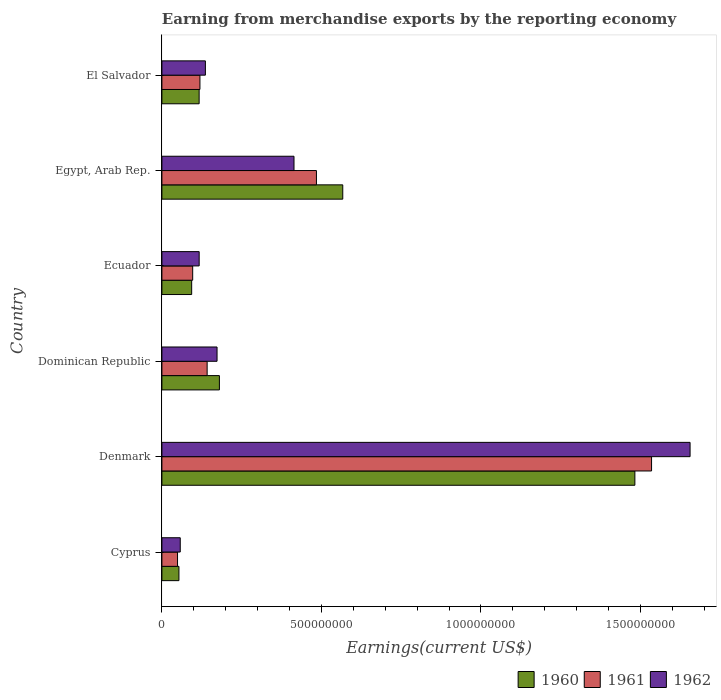Are the number of bars per tick equal to the number of legend labels?
Make the answer very short. Yes. How many bars are there on the 3rd tick from the top?
Ensure brevity in your answer.  3. What is the label of the 3rd group of bars from the top?
Provide a short and direct response. Ecuador. In how many cases, is the number of bars for a given country not equal to the number of legend labels?
Provide a succinct answer. 0. What is the amount earned from merchandise exports in 1961 in Dominican Republic?
Make the answer very short. 1.42e+08. Across all countries, what is the maximum amount earned from merchandise exports in 1961?
Make the answer very short. 1.53e+09. Across all countries, what is the minimum amount earned from merchandise exports in 1961?
Make the answer very short. 4.90e+07. In which country was the amount earned from merchandise exports in 1961 minimum?
Keep it short and to the point. Cyprus. What is the total amount earned from merchandise exports in 1960 in the graph?
Keep it short and to the point. 2.49e+09. What is the difference between the amount earned from merchandise exports in 1962 in Cyprus and that in Ecuador?
Your answer should be compact. -5.93e+07. What is the difference between the amount earned from merchandise exports in 1961 in El Salvador and the amount earned from merchandise exports in 1962 in Dominican Republic?
Provide a short and direct response. -5.36e+07. What is the average amount earned from merchandise exports in 1962 per country?
Offer a very short reply. 4.25e+08. What is the difference between the amount earned from merchandise exports in 1961 and amount earned from merchandise exports in 1960 in Egypt, Arab Rep.?
Your answer should be compact. -8.25e+07. In how many countries, is the amount earned from merchandise exports in 1962 greater than 1500000000 US$?
Your answer should be very brief. 1. What is the ratio of the amount earned from merchandise exports in 1960 in Denmark to that in Dominican Republic?
Ensure brevity in your answer.  8.23. What is the difference between the highest and the second highest amount earned from merchandise exports in 1960?
Your response must be concise. 9.16e+08. What is the difference between the highest and the lowest amount earned from merchandise exports in 1961?
Keep it short and to the point. 1.49e+09. Is the sum of the amount earned from merchandise exports in 1961 in Cyprus and Egypt, Arab Rep. greater than the maximum amount earned from merchandise exports in 1960 across all countries?
Your answer should be compact. No. What does the 3rd bar from the top in Denmark represents?
Your answer should be very brief. 1960. Is it the case that in every country, the sum of the amount earned from merchandise exports in 1962 and amount earned from merchandise exports in 1960 is greater than the amount earned from merchandise exports in 1961?
Provide a succinct answer. Yes. How many bars are there?
Ensure brevity in your answer.  18. How many countries are there in the graph?
Provide a short and direct response. 6. What is the difference between two consecutive major ticks on the X-axis?
Your answer should be very brief. 5.00e+08. Are the values on the major ticks of X-axis written in scientific E-notation?
Provide a short and direct response. No. Does the graph contain any zero values?
Offer a terse response. No. What is the title of the graph?
Offer a very short reply. Earning from merchandise exports by the reporting economy. Does "2002" appear as one of the legend labels in the graph?
Give a very brief answer. No. What is the label or title of the X-axis?
Ensure brevity in your answer.  Earnings(current US$). What is the Earnings(current US$) of 1960 in Cyprus?
Give a very brief answer. 5.34e+07. What is the Earnings(current US$) of 1961 in Cyprus?
Provide a succinct answer. 4.90e+07. What is the Earnings(current US$) in 1962 in Cyprus?
Your answer should be compact. 5.75e+07. What is the Earnings(current US$) in 1960 in Denmark?
Your response must be concise. 1.48e+09. What is the Earnings(current US$) in 1961 in Denmark?
Provide a succinct answer. 1.53e+09. What is the Earnings(current US$) in 1962 in Denmark?
Make the answer very short. 1.66e+09. What is the Earnings(current US$) of 1960 in Dominican Republic?
Keep it short and to the point. 1.80e+08. What is the Earnings(current US$) of 1961 in Dominican Republic?
Give a very brief answer. 1.42e+08. What is the Earnings(current US$) of 1962 in Dominican Republic?
Offer a terse response. 1.73e+08. What is the Earnings(current US$) in 1960 in Ecuador?
Make the answer very short. 9.33e+07. What is the Earnings(current US$) in 1961 in Ecuador?
Your response must be concise. 9.65e+07. What is the Earnings(current US$) in 1962 in Ecuador?
Make the answer very short. 1.17e+08. What is the Earnings(current US$) in 1960 in Egypt, Arab Rep.?
Give a very brief answer. 5.67e+08. What is the Earnings(current US$) in 1961 in Egypt, Arab Rep.?
Provide a short and direct response. 4.84e+08. What is the Earnings(current US$) of 1962 in Egypt, Arab Rep.?
Keep it short and to the point. 4.14e+08. What is the Earnings(current US$) in 1960 in El Salvador?
Offer a very short reply. 1.17e+08. What is the Earnings(current US$) of 1961 in El Salvador?
Your answer should be compact. 1.19e+08. What is the Earnings(current US$) in 1962 in El Salvador?
Your response must be concise. 1.36e+08. Across all countries, what is the maximum Earnings(current US$) in 1960?
Your answer should be very brief. 1.48e+09. Across all countries, what is the maximum Earnings(current US$) of 1961?
Offer a very short reply. 1.53e+09. Across all countries, what is the maximum Earnings(current US$) of 1962?
Keep it short and to the point. 1.66e+09. Across all countries, what is the minimum Earnings(current US$) in 1960?
Ensure brevity in your answer.  5.34e+07. Across all countries, what is the minimum Earnings(current US$) in 1961?
Ensure brevity in your answer.  4.90e+07. Across all countries, what is the minimum Earnings(current US$) in 1962?
Keep it short and to the point. 5.75e+07. What is the total Earnings(current US$) of 1960 in the graph?
Your response must be concise. 2.49e+09. What is the total Earnings(current US$) in 1961 in the graph?
Your response must be concise. 2.43e+09. What is the total Earnings(current US$) of 1962 in the graph?
Your response must be concise. 2.55e+09. What is the difference between the Earnings(current US$) of 1960 in Cyprus and that in Denmark?
Ensure brevity in your answer.  -1.43e+09. What is the difference between the Earnings(current US$) of 1961 in Cyprus and that in Denmark?
Give a very brief answer. -1.49e+09. What is the difference between the Earnings(current US$) of 1962 in Cyprus and that in Denmark?
Keep it short and to the point. -1.60e+09. What is the difference between the Earnings(current US$) in 1960 in Cyprus and that in Dominican Republic?
Make the answer very short. -1.27e+08. What is the difference between the Earnings(current US$) in 1961 in Cyprus and that in Dominican Republic?
Ensure brevity in your answer.  -9.28e+07. What is the difference between the Earnings(current US$) in 1962 in Cyprus and that in Dominican Republic?
Your answer should be very brief. -1.15e+08. What is the difference between the Earnings(current US$) of 1960 in Cyprus and that in Ecuador?
Provide a succinct answer. -3.99e+07. What is the difference between the Earnings(current US$) in 1961 in Cyprus and that in Ecuador?
Offer a very short reply. -4.75e+07. What is the difference between the Earnings(current US$) in 1962 in Cyprus and that in Ecuador?
Your answer should be compact. -5.93e+07. What is the difference between the Earnings(current US$) of 1960 in Cyprus and that in Egypt, Arab Rep.?
Make the answer very short. -5.13e+08. What is the difference between the Earnings(current US$) of 1961 in Cyprus and that in Egypt, Arab Rep.?
Provide a short and direct response. -4.35e+08. What is the difference between the Earnings(current US$) of 1962 in Cyprus and that in Egypt, Arab Rep.?
Keep it short and to the point. -3.56e+08. What is the difference between the Earnings(current US$) in 1960 in Cyprus and that in El Salvador?
Your answer should be compact. -6.33e+07. What is the difference between the Earnings(current US$) in 1961 in Cyprus and that in El Salvador?
Keep it short and to the point. -7.02e+07. What is the difference between the Earnings(current US$) of 1962 in Cyprus and that in El Salvador?
Ensure brevity in your answer.  -7.88e+07. What is the difference between the Earnings(current US$) of 1960 in Denmark and that in Dominican Republic?
Make the answer very short. 1.30e+09. What is the difference between the Earnings(current US$) in 1961 in Denmark and that in Dominican Republic?
Give a very brief answer. 1.39e+09. What is the difference between the Earnings(current US$) in 1962 in Denmark and that in Dominican Republic?
Your answer should be very brief. 1.48e+09. What is the difference between the Earnings(current US$) of 1960 in Denmark and that in Ecuador?
Your answer should be very brief. 1.39e+09. What is the difference between the Earnings(current US$) of 1961 in Denmark and that in Ecuador?
Offer a terse response. 1.44e+09. What is the difference between the Earnings(current US$) in 1962 in Denmark and that in Ecuador?
Provide a short and direct response. 1.54e+09. What is the difference between the Earnings(current US$) in 1960 in Denmark and that in Egypt, Arab Rep.?
Offer a very short reply. 9.16e+08. What is the difference between the Earnings(current US$) of 1961 in Denmark and that in Egypt, Arab Rep.?
Provide a succinct answer. 1.05e+09. What is the difference between the Earnings(current US$) in 1962 in Denmark and that in Egypt, Arab Rep.?
Provide a short and direct response. 1.24e+09. What is the difference between the Earnings(current US$) in 1960 in Denmark and that in El Salvador?
Offer a very short reply. 1.37e+09. What is the difference between the Earnings(current US$) of 1961 in Denmark and that in El Salvador?
Provide a short and direct response. 1.42e+09. What is the difference between the Earnings(current US$) of 1962 in Denmark and that in El Salvador?
Make the answer very short. 1.52e+09. What is the difference between the Earnings(current US$) in 1960 in Dominican Republic and that in Ecuador?
Make the answer very short. 8.69e+07. What is the difference between the Earnings(current US$) in 1961 in Dominican Republic and that in Ecuador?
Your response must be concise. 4.53e+07. What is the difference between the Earnings(current US$) in 1962 in Dominican Republic and that in Ecuador?
Your answer should be very brief. 5.60e+07. What is the difference between the Earnings(current US$) in 1960 in Dominican Republic and that in Egypt, Arab Rep.?
Make the answer very short. -3.87e+08. What is the difference between the Earnings(current US$) in 1961 in Dominican Republic and that in Egypt, Arab Rep.?
Offer a terse response. -3.42e+08. What is the difference between the Earnings(current US$) in 1962 in Dominican Republic and that in Egypt, Arab Rep.?
Offer a terse response. -2.41e+08. What is the difference between the Earnings(current US$) of 1960 in Dominican Republic and that in El Salvador?
Provide a short and direct response. 6.35e+07. What is the difference between the Earnings(current US$) in 1961 in Dominican Republic and that in El Salvador?
Your answer should be compact. 2.26e+07. What is the difference between the Earnings(current US$) of 1962 in Dominican Republic and that in El Salvador?
Offer a very short reply. 3.65e+07. What is the difference between the Earnings(current US$) in 1960 in Ecuador and that in Egypt, Arab Rep.?
Offer a terse response. -4.74e+08. What is the difference between the Earnings(current US$) of 1961 in Ecuador and that in Egypt, Arab Rep.?
Your answer should be very brief. -3.88e+08. What is the difference between the Earnings(current US$) in 1962 in Ecuador and that in Egypt, Arab Rep.?
Provide a succinct answer. -2.97e+08. What is the difference between the Earnings(current US$) in 1960 in Ecuador and that in El Salvador?
Keep it short and to the point. -2.34e+07. What is the difference between the Earnings(current US$) of 1961 in Ecuador and that in El Salvador?
Your response must be concise. -2.27e+07. What is the difference between the Earnings(current US$) in 1962 in Ecuador and that in El Salvador?
Offer a very short reply. -1.95e+07. What is the difference between the Earnings(current US$) of 1960 in Egypt, Arab Rep. and that in El Salvador?
Your response must be concise. 4.50e+08. What is the difference between the Earnings(current US$) in 1961 in Egypt, Arab Rep. and that in El Salvador?
Give a very brief answer. 3.65e+08. What is the difference between the Earnings(current US$) in 1962 in Egypt, Arab Rep. and that in El Salvador?
Give a very brief answer. 2.78e+08. What is the difference between the Earnings(current US$) in 1960 in Cyprus and the Earnings(current US$) in 1961 in Denmark?
Ensure brevity in your answer.  -1.48e+09. What is the difference between the Earnings(current US$) of 1960 in Cyprus and the Earnings(current US$) of 1962 in Denmark?
Offer a terse response. -1.60e+09. What is the difference between the Earnings(current US$) in 1961 in Cyprus and the Earnings(current US$) in 1962 in Denmark?
Ensure brevity in your answer.  -1.61e+09. What is the difference between the Earnings(current US$) of 1960 in Cyprus and the Earnings(current US$) of 1961 in Dominican Republic?
Give a very brief answer. -8.84e+07. What is the difference between the Earnings(current US$) in 1960 in Cyprus and the Earnings(current US$) in 1962 in Dominican Republic?
Your response must be concise. -1.19e+08. What is the difference between the Earnings(current US$) in 1961 in Cyprus and the Earnings(current US$) in 1962 in Dominican Republic?
Provide a short and direct response. -1.24e+08. What is the difference between the Earnings(current US$) in 1960 in Cyprus and the Earnings(current US$) in 1961 in Ecuador?
Offer a very short reply. -4.31e+07. What is the difference between the Earnings(current US$) of 1960 in Cyprus and the Earnings(current US$) of 1962 in Ecuador?
Provide a succinct answer. -6.34e+07. What is the difference between the Earnings(current US$) in 1961 in Cyprus and the Earnings(current US$) in 1962 in Ecuador?
Give a very brief answer. -6.78e+07. What is the difference between the Earnings(current US$) of 1960 in Cyprus and the Earnings(current US$) of 1961 in Egypt, Arab Rep.?
Provide a short and direct response. -4.31e+08. What is the difference between the Earnings(current US$) of 1960 in Cyprus and the Earnings(current US$) of 1962 in Egypt, Arab Rep.?
Provide a succinct answer. -3.61e+08. What is the difference between the Earnings(current US$) of 1961 in Cyprus and the Earnings(current US$) of 1962 in Egypt, Arab Rep.?
Ensure brevity in your answer.  -3.65e+08. What is the difference between the Earnings(current US$) of 1960 in Cyprus and the Earnings(current US$) of 1961 in El Salvador?
Your answer should be compact. -6.58e+07. What is the difference between the Earnings(current US$) of 1960 in Cyprus and the Earnings(current US$) of 1962 in El Salvador?
Offer a very short reply. -8.29e+07. What is the difference between the Earnings(current US$) in 1961 in Cyprus and the Earnings(current US$) in 1962 in El Salvador?
Give a very brief answer. -8.73e+07. What is the difference between the Earnings(current US$) in 1960 in Denmark and the Earnings(current US$) in 1961 in Dominican Republic?
Make the answer very short. 1.34e+09. What is the difference between the Earnings(current US$) of 1960 in Denmark and the Earnings(current US$) of 1962 in Dominican Republic?
Your response must be concise. 1.31e+09. What is the difference between the Earnings(current US$) in 1961 in Denmark and the Earnings(current US$) in 1962 in Dominican Republic?
Ensure brevity in your answer.  1.36e+09. What is the difference between the Earnings(current US$) in 1960 in Denmark and the Earnings(current US$) in 1961 in Ecuador?
Your answer should be compact. 1.39e+09. What is the difference between the Earnings(current US$) in 1960 in Denmark and the Earnings(current US$) in 1962 in Ecuador?
Keep it short and to the point. 1.37e+09. What is the difference between the Earnings(current US$) of 1961 in Denmark and the Earnings(current US$) of 1962 in Ecuador?
Your answer should be compact. 1.42e+09. What is the difference between the Earnings(current US$) of 1960 in Denmark and the Earnings(current US$) of 1961 in Egypt, Arab Rep.?
Your answer should be very brief. 9.98e+08. What is the difference between the Earnings(current US$) of 1960 in Denmark and the Earnings(current US$) of 1962 in Egypt, Arab Rep.?
Your answer should be very brief. 1.07e+09. What is the difference between the Earnings(current US$) of 1961 in Denmark and the Earnings(current US$) of 1962 in Egypt, Arab Rep.?
Offer a very short reply. 1.12e+09. What is the difference between the Earnings(current US$) of 1960 in Denmark and the Earnings(current US$) of 1961 in El Salvador?
Your answer should be compact. 1.36e+09. What is the difference between the Earnings(current US$) of 1960 in Denmark and the Earnings(current US$) of 1962 in El Salvador?
Provide a short and direct response. 1.35e+09. What is the difference between the Earnings(current US$) of 1961 in Denmark and the Earnings(current US$) of 1962 in El Salvador?
Provide a short and direct response. 1.40e+09. What is the difference between the Earnings(current US$) of 1960 in Dominican Republic and the Earnings(current US$) of 1961 in Ecuador?
Keep it short and to the point. 8.37e+07. What is the difference between the Earnings(current US$) of 1960 in Dominican Republic and the Earnings(current US$) of 1962 in Ecuador?
Make the answer very short. 6.34e+07. What is the difference between the Earnings(current US$) of 1961 in Dominican Republic and the Earnings(current US$) of 1962 in Ecuador?
Make the answer very short. 2.50e+07. What is the difference between the Earnings(current US$) of 1960 in Dominican Republic and the Earnings(current US$) of 1961 in Egypt, Arab Rep.?
Provide a short and direct response. -3.04e+08. What is the difference between the Earnings(current US$) in 1960 in Dominican Republic and the Earnings(current US$) in 1962 in Egypt, Arab Rep.?
Your answer should be compact. -2.34e+08. What is the difference between the Earnings(current US$) of 1961 in Dominican Republic and the Earnings(current US$) of 1962 in Egypt, Arab Rep.?
Keep it short and to the point. -2.72e+08. What is the difference between the Earnings(current US$) of 1960 in Dominican Republic and the Earnings(current US$) of 1961 in El Salvador?
Your response must be concise. 6.10e+07. What is the difference between the Earnings(current US$) of 1960 in Dominican Republic and the Earnings(current US$) of 1962 in El Salvador?
Provide a succinct answer. 4.39e+07. What is the difference between the Earnings(current US$) of 1961 in Dominican Republic and the Earnings(current US$) of 1962 in El Salvador?
Your answer should be very brief. 5.50e+06. What is the difference between the Earnings(current US$) of 1960 in Ecuador and the Earnings(current US$) of 1961 in Egypt, Arab Rep.?
Keep it short and to the point. -3.91e+08. What is the difference between the Earnings(current US$) of 1960 in Ecuador and the Earnings(current US$) of 1962 in Egypt, Arab Rep.?
Ensure brevity in your answer.  -3.21e+08. What is the difference between the Earnings(current US$) of 1961 in Ecuador and the Earnings(current US$) of 1962 in Egypt, Arab Rep.?
Your response must be concise. -3.18e+08. What is the difference between the Earnings(current US$) in 1960 in Ecuador and the Earnings(current US$) in 1961 in El Salvador?
Provide a succinct answer. -2.59e+07. What is the difference between the Earnings(current US$) in 1960 in Ecuador and the Earnings(current US$) in 1962 in El Salvador?
Give a very brief answer. -4.30e+07. What is the difference between the Earnings(current US$) of 1961 in Ecuador and the Earnings(current US$) of 1962 in El Salvador?
Your answer should be compact. -3.98e+07. What is the difference between the Earnings(current US$) of 1960 in Egypt, Arab Rep. and the Earnings(current US$) of 1961 in El Salvador?
Offer a very short reply. 4.48e+08. What is the difference between the Earnings(current US$) of 1960 in Egypt, Arab Rep. and the Earnings(current US$) of 1962 in El Salvador?
Make the answer very short. 4.30e+08. What is the difference between the Earnings(current US$) of 1961 in Egypt, Arab Rep. and the Earnings(current US$) of 1962 in El Salvador?
Give a very brief answer. 3.48e+08. What is the average Earnings(current US$) of 1960 per country?
Your answer should be very brief. 4.15e+08. What is the average Earnings(current US$) in 1961 per country?
Your response must be concise. 4.04e+08. What is the average Earnings(current US$) of 1962 per country?
Give a very brief answer. 4.25e+08. What is the difference between the Earnings(current US$) in 1960 and Earnings(current US$) in 1961 in Cyprus?
Offer a very short reply. 4.40e+06. What is the difference between the Earnings(current US$) of 1960 and Earnings(current US$) of 1962 in Cyprus?
Offer a very short reply. -4.10e+06. What is the difference between the Earnings(current US$) in 1961 and Earnings(current US$) in 1962 in Cyprus?
Your response must be concise. -8.50e+06. What is the difference between the Earnings(current US$) in 1960 and Earnings(current US$) in 1961 in Denmark?
Make the answer very short. -5.23e+07. What is the difference between the Earnings(current US$) in 1960 and Earnings(current US$) in 1962 in Denmark?
Keep it short and to the point. -1.73e+08. What is the difference between the Earnings(current US$) of 1961 and Earnings(current US$) of 1962 in Denmark?
Give a very brief answer. -1.21e+08. What is the difference between the Earnings(current US$) in 1960 and Earnings(current US$) in 1961 in Dominican Republic?
Offer a terse response. 3.84e+07. What is the difference between the Earnings(current US$) in 1960 and Earnings(current US$) in 1962 in Dominican Republic?
Your answer should be compact. 7.38e+06. What is the difference between the Earnings(current US$) in 1961 and Earnings(current US$) in 1962 in Dominican Republic?
Offer a very short reply. -3.10e+07. What is the difference between the Earnings(current US$) in 1960 and Earnings(current US$) in 1961 in Ecuador?
Offer a very short reply. -3.20e+06. What is the difference between the Earnings(current US$) in 1960 and Earnings(current US$) in 1962 in Ecuador?
Keep it short and to the point. -2.35e+07. What is the difference between the Earnings(current US$) of 1961 and Earnings(current US$) of 1962 in Ecuador?
Make the answer very short. -2.03e+07. What is the difference between the Earnings(current US$) in 1960 and Earnings(current US$) in 1961 in Egypt, Arab Rep.?
Provide a short and direct response. 8.25e+07. What is the difference between the Earnings(current US$) in 1960 and Earnings(current US$) in 1962 in Egypt, Arab Rep.?
Ensure brevity in your answer.  1.53e+08. What is the difference between the Earnings(current US$) in 1961 and Earnings(current US$) in 1962 in Egypt, Arab Rep.?
Offer a very short reply. 7.03e+07. What is the difference between the Earnings(current US$) of 1960 and Earnings(current US$) of 1961 in El Salvador?
Give a very brief answer. -2.50e+06. What is the difference between the Earnings(current US$) of 1960 and Earnings(current US$) of 1962 in El Salvador?
Ensure brevity in your answer.  -1.96e+07. What is the difference between the Earnings(current US$) in 1961 and Earnings(current US$) in 1962 in El Salvador?
Make the answer very short. -1.71e+07. What is the ratio of the Earnings(current US$) of 1960 in Cyprus to that in Denmark?
Offer a terse response. 0.04. What is the ratio of the Earnings(current US$) of 1961 in Cyprus to that in Denmark?
Make the answer very short. 0.03. What is the ratio of the Earnings(current US$) of 1962 in Cyprus to that in Denmark?
Keep it short and to the point. 0.03. What is the ratio of the Earnings(current US$) in 1960 in Cyprus to that in Dominican Republic?
Keep it short and to the point. 0.3. What is the ratio of the Earnings(current US$) of 1961 in Cyprus to that in Dominican Republic?
Ensure brevity in your answer.  0.35. What is the ratio of the Earnings(current US$) of 1962 in Cyprus to that in Dominican Republic?
Keep it short and to the point. 0.33. What is the ratio of the Earnings(current US$) of 1960 in Cyprus to that in Ecuador?
Ensure brevity in your answer.  0.57. What is the ratio of the Earnings(current US$) in 1961 in Cyprus to that in Ecuador?
Keep it short and to the point. 0.51. What is the ratio of the Earnings(current US$) in 1962 in Cyprus to that in Ecuador?
Offer a very short reply. 0.49. What is the ratio of the Earnings(current US$) of 1960 in Cyprus to that in Egypt, Arab Rep.?
Provide a short and direct response. 0.09. What is the ratio of the Earnings(current US$) in 1961 in Cyprus to that in Egypt, Arab Rep.?
Make the answer very short. 0.1. What is the ratio of the Earnings(current US$) in 1962 in Cyprus to that in Egypt, Arab Rep.?
Your answer should be compact. 0.14. What is the ratio of the Earnings(current US$) in 1960 in Cyprus to that in El Salvador?
Offer a very short reply. 0.46. What is the ratio of the Earnings(current US$) of 1961 in Cyprus to that in El Salvador?
Ensure brevity in your answer.  0.41. What is the ratio of the Earnings(current US$) of 1962 in Cyprus to that in El Salvador?
Make the answer very short. 0.42. What is the ratio of the Earnings(current US$) of 1960 in Denmark to that in Dominican Republic?
Your answer should be compact. 8.23. What is the ratio of the Earnings(current US$) of 1961 in Denmark to that in Dominican Republic?
Offer a very short reply. 10.82. What is the ratio of the Earnings(current US$) in 1962 in Denmark to that in Dominican Republic?
Your answer should be compact. 9.58. What is the ratio of the Earnings(current US$) of 1960 in Denmark to that in Ecuador?
Your answer should be very brief. 15.89. What is the ratio of the Earnings(current US$) of 1961 in Denmark to that in Ecuador?
Ensure brevity in your answer.  15.9. What is the ratio of the Earnings(current US$) of 1962 in Denmark to that in Ecuador?
Offer a terse response. 14.17. What is the ratio of the Earnings(current US$) of 1960 in Denmark to that in Egypt, Arab Rep.?
Your response must be concise. 2.62. What is the ratio of the Earnings(current US$) of 1961 in Denmark to that in Egypt, Arab Rep.?
Provide a short and direct response. 3.17. What is the ratio of the Earnings(current US$) of 1962 in Denmark to that in Egypt, Arab Rep.?
Provide a succinct answer. 4. What is the ratio of the Earnings(current US$) of 1960 in Denmark to that in El Salvador?
Provide a succinct answer. 12.7. What is the ratio of the Earnings(current US$) of 1961 in Denmark to that in El Salvador?
Your answer should be compact. 12.87. What is the ratio of the Earnings(current US$) of 1962 in Denmark to that in El Salvador?
Ensure brevity in your answer.  12.14. What is the ratio of the Earnings(current US$) in 1960 in Dominican Republic to that in Ecuador?
Ensure brevity in your answer.  1.93. What is the ratio of the Earnings(current US$) in 1961 in Dominican Republic to that in Ecuador?
Offer a terse response. 1.47. What is the ratio of the Earnings(current US$) in 1962 in Dominican Republic to that in Ecuador?
Ensure brevity in your answer.  1.48. What is the ratio of the Earnings(current US$) of 1960 in Dominican Republic to that in Egypt, Arab Rep.?
Offer a very short reply. 0.32. What is the ratio of the Earnings(current US$) of 1961 in Dominican Republic to that in Egypt, Arab Rep.?
Your answer should be very brief. 0.29. What is the ratio of the Earnings(current US$) in 1962 in Dominican Republic to that in Egypt, Arab Rep.?
Give a very brief answer. 0.42. What is the ratio of the Earnings(current US$) in 1960 in Dominican Republic to that in El Salvador?
Ensure brevity in your answer.  1.54. What is the ratio of the Earnings(current US$) of 1961 in Dominican Republic to that in El Salvador?
Make the answer very short. 1.19. What is the ratio of the Earnings(current US$) in 1962 in Dominican Republic to that in El Salvador?
Your answer should be very brief. 1.27. What is the ratio of the Earnings(current US$) in 1960 in Ecuador to that in Egypt, Arab Rep.?
Keep it short and to the point. 0.16. What is the ratio of the Earnings(current US$) in 1961 in Ecuador to that in Egypt, Arab Rep.?
Keep it short and to the point. 0.2. What is the ratio of the Earnings(current US$) of 1962 in Ecuador to that in Egypt, Arab Rep.?
Provide a succinct answer. 0.28. What is the ratio of the Earnings(current US$) of 1960 in Ecuador to that in El Salvador?
Keep it short and to the point. 0.8. What is the ratio of the Earnings(current US$) in 1961 in Ecuador to that in El Salvador?
Ensure brevity in your answer.  0.81. What is the ratio of the Earnings(current US$) of 1962 in Ecuador to that in El Salvador?
Your answer should be very brief. 0.86. What is the ratio of the Earnings(current US$) in 1960 in Egypt, Arab Rep. to that in El Salvador?
Your response must be concise. 4.86. What is the ratio of the Earnings(current US$) in 1961 in Egypt, Arab Rep. to that in El Salvador?
Your response must be concise. 4.06. What is the ratio of the Earnings(current US$) of 1962 in Egypt, Arab Rep. to that in El Salvador?
Give a very brief answer. 3.04. What is the difference between the highest and the second highest Earnings(current US$) in 1960?
Keep it short and to the point. 9.16e+08. What is the difference between the highest and the second highest Earnings(current US$) of 1961?
Offer a very short reply. 1.05e+09. What is the difference between the highest and the second highest Earnings(current US$) in 1962?
Your answer should be very brief. 1.24e+09. What is the difference between the highest and the lowest Earnings(current US$) of 1960?
Ensure brevity in your answer.  1.43e+09. What is the difference between the highest and the lowest Earnings(current US$) in 1961?
Keep it short and to the point. 1.49e+09. What is the difference between the highest and the lowest Earnings(current US$) in 1962?
Provide a short and direct response. 1.60e+09. 